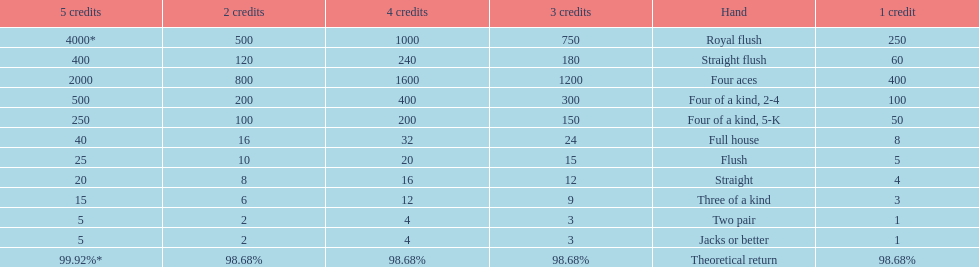At most, what could a person earn for having a full house? 40. 